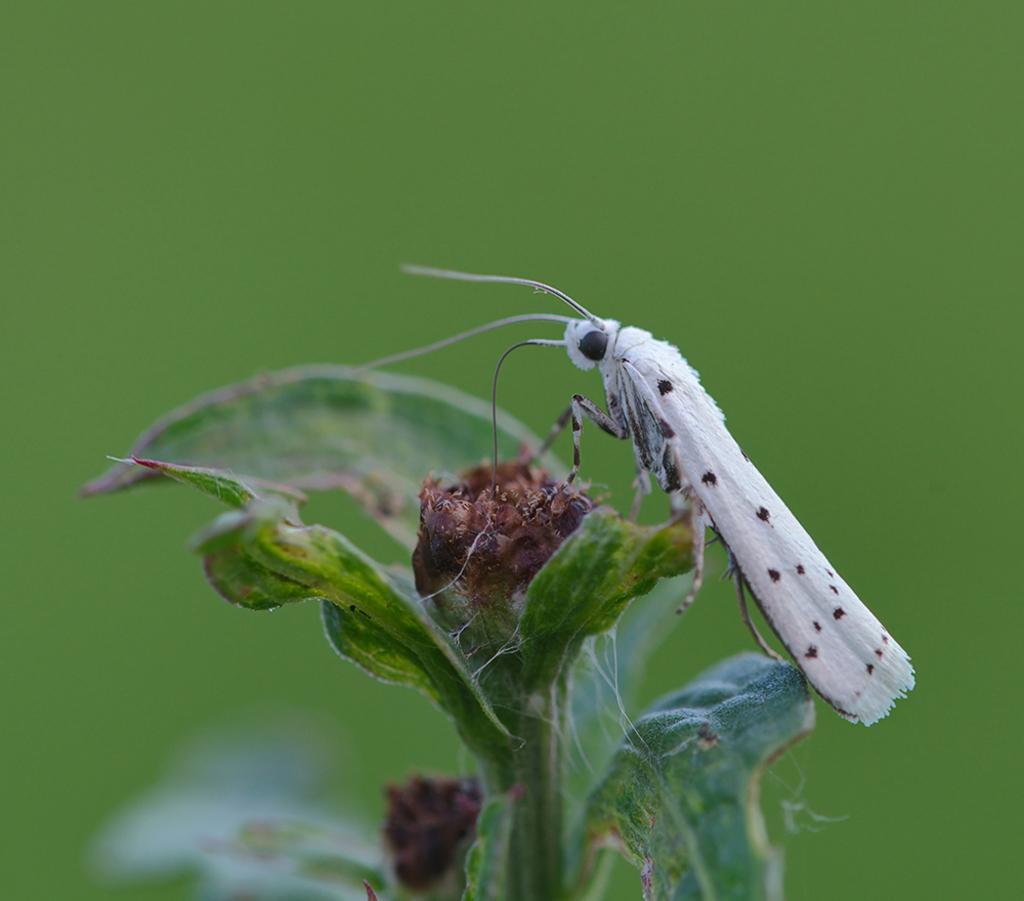Please provide a concise description of this image. In the image we can see an insect, white and black in color. The insect is sitting on the plant and the background is green in color. 